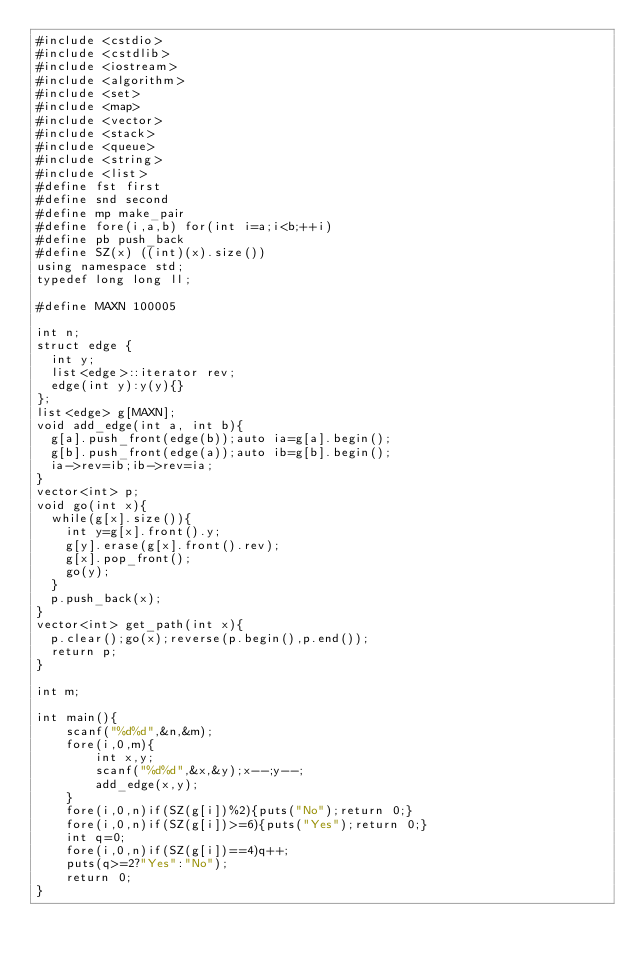Convert code to text. <code><loc_0><loc_0><loc_500><loc_500><_C++_>#include <cstdio>
#include <cstdlib>
#include <iostream>
#include <algorithm>
#include <set>
#include <map>
#include <vector>
#include <stack>
#include <queue>
#include <string>
#include <list>
#define fst first
#define snd second
#define mp make_pair
#define fore(i,a,b) for(int i=a;i<b;++i)
#define pb push_back
#define SZ(x) ((int)(x).size())
using namespace std;
typedef long long ll;

#define MAXN 100005

int n;
struct edge {
	int y;
	list<edge>::iterator rev;
	edge(int y):y(y){}
};
list<edge> g[MAXN];
void add_edge(int a, int b){
	g[a].push_front(edge(b));auto ia=g[a].begin();
	g[b].push_front(edge(a));auto ib=g[b].begin();
	ia->rev=ib;ib->rev=ia;
}
vector<int> p;
void go(int x){
	while(g[x].size()){
		int y=g[x].front().y;
		g[y].erase(g[x].front().rev);
		g[x].pop_front();
		go(y);
	}
	p.push_back(x);
}
vector<int> get_path(int x){
	p.clear();go(x);reverse(p.begin(),p.end());
	return p;
}

int m;

int main(){
    scanf("%d%d",&n,&m);
    fore(i,0,m){
        int x,y;
        scanf("%d%d",&x,&y);x--;y--;
        add_edge(x,y);
    }
    fore(i,0,n)if(SZ(g[i])%2){puts("No");return 0;}
    fore(i,0,n)if(SZ(g[i])>=6){puts("Yes");return 0;}
    int q=0;
    fore(i,0,n)if(SZ(g[i])==4)q++;
    puts(q>=2?"Yes":"No");
    return 0;
}
</code> 